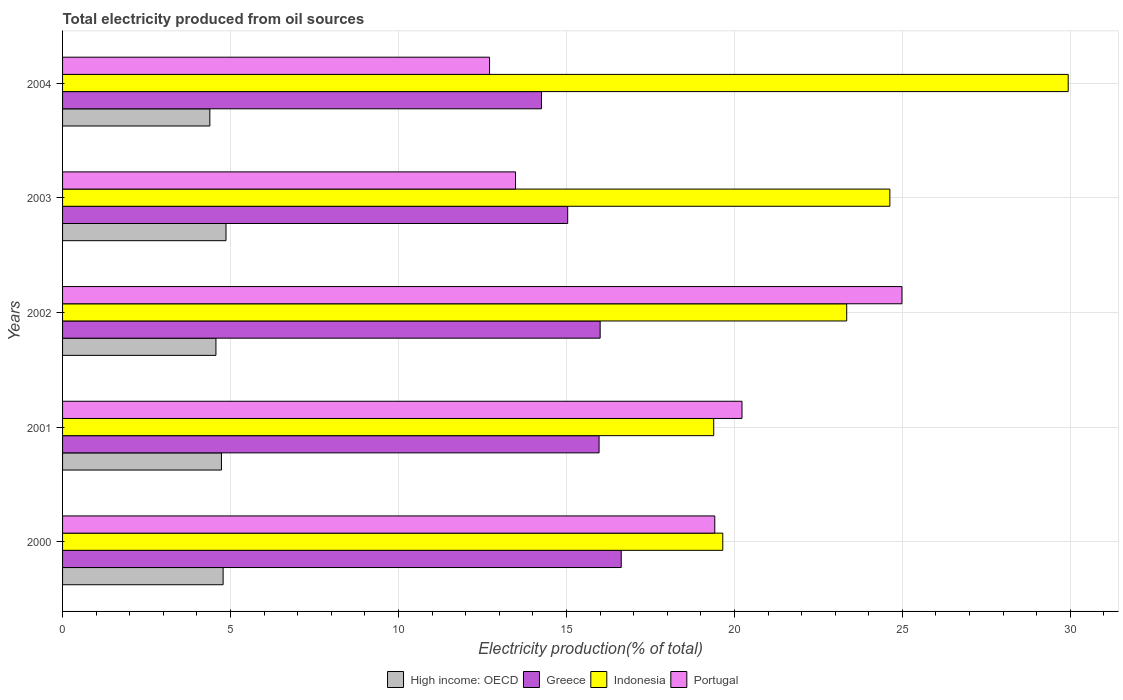How many different coloured bars are there?
Provide a short and direct response. 4. What is the label of the 1st group of bars from the top?
Ensure brevity in your answer.  2004. What is the total electricity produced in Portugal in 2002?
Provide a succinct answer. 24.99. Across all years, what is the maximum total electricity produced in Portugal?
Provide a succinct answer. 24.99. Across all years, what is the minimum total electricity produced in Greece?
Ensure brevity in your answer.  14.26. In which year was the total electricity produced in Indonesia maximum?
Ensure brevity in your answer.  2004. What is the total total electricity produced in High income: OECD in the graph?
Provide a short and direct response. 23.33. What is the difference between the total electricity produced in Portugal in 2000 and that in 2002?
Offer a terse response. -5.57. What is the difference between the total electricity produced in Indonesia in 2000 and the total electricity produced in High income: OECD in 2002?
Your answer should be compact. 15.09. What is the average total electricity produced in Greece per year?
Provide a short and direct response. 15.58. In the year 2001, what is the difference between the total electricity produced in Portugal and total electricity produced in Greece?
Provide a short and direct response. 4.25. What is the ratio of the total electricity produced in Portugal in 2003 to that in 2004?
Offer a very short reply. 1.06. Is the difference between the total electricity produced in Portugal in 2003 and 2004 greater than the difference between the total electricity produced in Greece in 2003 and 2004?
Make the answer very short. No. What is the difference between the highest and the second highest total electricity produced in High income: OECD?
Make the answer very short. 0.09. What is the difference between the highest and the lowest total electricity produced in Portugal?
Your answer should be very brief. 12.28. Is the sum of the total electricity produced in Portugal in 2001 and 2003 greater than the maximum total electricity produced in Greece across all years?
Offer a terse response. Yes. What does the 3rd bar from the top in 2003 represents?
Keep it short and to the point. Greece. What does the 1st bar from the bottom in 2004 represents?
Your answer should be compact. High income: OECD. How many bars are there?
Provide a short and direct response. 20. What is the difference between two consecutive major ticks on the X-axis?
Offer a very short reply. 5. Does the graph contain any zero values?
Offer a terse response. No. Where does the legend appear in the graph?
Your answer should be very brief. Bottom center. How many legend labels are there?
Your response must be concise. 4. How are the legend labels stacked?
Provide a short and direct response. Horizontal. What is the title of the graph?
Keep it short and to the point. Total electricity produced from oil sources. What is the Electricity production(% of total) of High income: OECD in 2000?
Provide a succinct answer. 4.78. What is the Electricity production(% of total) in Greece in 2000?
Your response must be concise. 16.63. What is the Electricity production(% of total) in Indonesia in 2000?
Offer a terse response. 19.65. What is the Electricity production(% of total) of Portugal in 2000?
Give a very brief answer. 19.42. What is the Electricity production(% of total) in High income: OECD in 2001?
Provide a short and direct response. 4.73. What is the Electricity production(% of total) in Greece in 2001?
Ensure brevity in your answer.  15.97. What is the Electricity production(% of total) of Indonesia in 2001?
Offer a terse response. 19.38. What is the Electricity production(% of total) in Portugal in 2001?
Ensure brevity in your answer.  20.23. What is the Electricity production(% of total) of High income: OECD in 2002?
Offer a very short reply. 4.57. What is the Electricity production(% of total) in Greece in 2002?
Your response must be concise. 16. What is the Electricity production(% of total) in Indonesia in 2002?
Your answer should be very brief. 23.34. What is the Electricity production(% of total) in Portugal in 2002?
Your response must be concise. 24.99. What is the Electricity production(% of total) of High income: OECD in 2003?
Ensure brevity in your answer.  4.87. What is the Electricity production(% of total) in Greece in 2003?
Keep it short and to the point. 15.04. What is the Electricity production(% of total) of Indonesia in 2003?
Your response must be concise. 24.63. What is the Electricity production(% of total) in Portugal in 2003?
Your answer should be compact. 13.48. What is the Electricity production(% of total) of High income: OECD in 2004?
Give a very brief answer. 4.38. What is the Electricity production(% of total) of Greece in 2004?
Keep it short and to the point. 14.26. What is the Electricity production(% of total) in Indonesia in 2004?
Provide a succinct answer. 29.94. What is the Electricity production(% of total) of Portugal in 2004?
Keep it short and to the point. 12.71. Across all years, what is the maximum Electricity production(% of total) of High income: OECD?
Give a very brief answer. 4.87. Across all years, what is the maximum Electricity production(% of total) of Greece?
Give a very brief answer. 16.63. Across all years, what is the maximum Electricity production(% of total) of Indonesia?
Make the answer very short. 29.94. Across all years, what is the maximum Electricity production(% of total) in Portugal?
Make the answer very short. 24.99. Across all years, what is the minimum Electricity production(% of total) in High income: OECD?
Make the answer very short. 4.38. Across all years, what is the minimum Electricity production(% of total) in Greece?
Your answer should be compact. 14.26. Across all years, what is the minimum Electricity production(% of total) of Indonesia?
Your response must be concise. 19.38. Across all years, what is the minimum Electricity production(% of total) in Portugal?
Your answer should be compact. 12.71. What is the total Electricity production(% of total) of High income: OECD in the graph?
Offer a terse response. 23.33. What is the total Electricity production(% of total) of Greece in the graph?
Provide a short and direct response. 77.9. What is the total Electricity production(% of total) in Indonesia in the graph?
Provide a short and direct response. 116.94. What is the total Electricity production(% of total) in Portugal in the graph?
Your response must be concise. 90.83. What is the difference between the Electricity production(% of total) in High income: OECD in 2000 and that in 2001?
Make the answer very short. 0.05. What is the difference between the Electricity production(% of total) in Greece in 2000 and that in 2001?
Offer a terse response. 0.66. What is the difference between the Electricity production(% of total) in Indonesia in 2000 and that in 2001?
Your answer should be compact. 0.27. What is the difference between the Electricity production(% of total) in Portugal in 2000 and that in 2001?
Your answer should be compact. -0.81. What is the difference between the Electricity production(% of total) in High income: OECD in 2000 and that in 2002?
Offer a terse response. 0.21. What is the difference between the Electricity production(% of total) of Greece in 2000 and that in 2002?
Your answer should be compact. 0.63. What is the difference between the Electricity production(% of total) of Indonesia in 2000 and that in 2002?
Provide a succinct answer. -3.69. What is the difference between the Electricity production(% of total) of Portugal in 2000 and that in 2002?
Give a very brief answer. -5.57. What is the difference between the Electricity production(% of total) of High income: OECD in 2000 and that in 2003?
Give a very brief answer. -0.09. What is the difference between the Electricity production(% of total) in Greece in 2000 and that in 2003?
Make the answer very short. 1.59. What is the difference between the Electricity production(% of total) in Indonesia in 2000 and that in 2003?
Provide a short and direct response. -4.97. What is the difference between the Electricity production(% of total) of Portugal in 2000 and that in 2003?
Provide a short and direct response. 5.93. What is the difference between the Electricity production(% of total) of High income: OECD in 2000 and that in 2004?
Your response must be concise. 0.4. What is the difference between the Electricity production(% of total) in Greece in 2000 and that in 2004?
Your response must be concise. 2.37. What is the difference between the Electricity production(% of total) of Indonesia in 2000 and that in 2004?
Ensure brevity in your answer.  -10.28. What is the difference between the Electricity production(% of total) in Portugal in 2000 and that in 2004?
Your answer should be compact. 6.7. What is the difference between the Electricity production(% of total) in High income: OECD in 2001 and that in 2002?
Give a very brief answer. 0.16. What is the difference between the Electricity production(% of total) of Greece in 2001 and that in 2002?
Your response must be concise. -0.03. What is the difference between the Electricity production(% of total) in Indonesia in 2001 and that in 2002?
Offer a terse response. -3.96. What is the difference between the Electricity production(% of total) of Portugal in 2001 and that in 2002?
Your response must be concise. -4.76. What is the difference between the Electricity production(% of total) in High income: OECD in 2001 and that in 2003?
Your answer should be very brief. -0.14. What is the difference between the Electricity production(% of total) of Greece in 2001 and that in 2003?
Your answer should be very brief. 0.93. What is the difference between the Electricity production(% of total) of Indonesia in 2001 and that in 2003?
Offer a terse response. -5.24. What is the difference between the Electricity production(% of total) in Portugal in 2001 and that in 2003?
Keep it short and to the point. 6.74. What is the difference between the Electricity production(% of total) of High income: OECD in 2001 and that in 2004?
Provide a succinct answer. 0.35. What is the difference between the Electricity production(% of total) of Greece in 2001 and that in 2004?
Your answer should be compact. 1.71. What is the difference between the Electricity production(% of total) in Indonesia in 2001 and that in 2004?
Your response must be concise. -10.55. What is the difference between the Electricity production(% of total) of Portugal in 2001 and that in 2004?
Your response must be concise. 7.51. What is the difference between the Electricity production(% of total) of High income: OECD in 2002 and that in 2003?
Your answer should be very brief. -0.3. What is the difference between the Electricity production(% of total) of Greece in 2002 and that in 2003?
Give a very brief answer. 0.97. What is the difference between the Electricity production(% of total) of Indonesia in 2002 and that in 2003?
Provide a succinct answer. -1.28. What is the difference between the Electricity production(% of total) in Portugal in 2002 and that in 2003?
Provide a succinct answer. 11.5. What is the difference between the Electricity production(% of total) of High income: OECD in 2002 and that in 2004?
Your response must be concise. 0.18. What is the difference between the Electricity production(% of total) of Greece in 2002 and that in 2004?
Provide a succinct answer. 1.75. What is the difference between the Electricity production(% of total) in Indonesia in 2002 and that in 2004?
Your answer should be compact. -6.59. What is the difference between the Electricity production(% of total) in Portugal in 2002 and that in 2004?
Offer a terse response. 12.28. What is the difference between the Electricity production(% of total) in High income: OECD in 2003 and that in 2004?
Your answer should be compact. 0.48. What is the difference between the Electricity production(% of total) in Greece in 2003 and that in 2004?
Ensure brevity in your answer.  0.78. What is the difference between the Electricity production(% of total) of Indonesia in 2003 and that in 2004?
Offer a very short reply. -5.31. What is the difference between the Electricity production(% of total) in Portugal in 2003 and that in 2004?
Provide a short and direct response. 0.77. What is the difference between the Electricity production(% of total) in High income: OECD in 2000 and the Electricity production(% of total) in Greece in 2001?
Make the answer very short. -11.19. What is the difference between the Electricity production(% of total) in High income: OECD in 2000 and the Electricity production(% of total) in Indonesia in 2001?
Keep it short and to the point. -14.6. What is the difference between the Electricity production(% of total) of High income: OECD in 2000 and the Electricity production(% of total) of Portugal in 2001?
Offer a terse response. -15.45. What is the difference between the Electricity production(% of total) in Greece in 2000 and the Electricity production(% of total) in Indonesia in 2001?
Your response must be concise. -2.75. What is the difference between the Electricity production(% of total) of Greece in 2000 and the Electricity production(% of total) of Portugal in 2001?
Ensure brevity in your answer.  -3.6. What is the difference between the Electricity production(% of total) in Indonesia in 2000 and the Electricity production(% of total) in Portugal in 2001?
Provide a short and direct response. -0.57. What is the difference between the Electricity production(% of total) of High income: OECD in 2000 and the Electricity production(% of total) of Greece in 2002?
Offer a terse response. -11.22. What is the difference between the Electricity production(% of total) of High income: OECD in 2000 and the Electricity production(% of total) of Indonesia in 2002?
Your answer should be compact. -18.56. What is the difference between the Electricity production(% of total) in High income: OECD in 2000 and the Electricity production(% of total) in Portugal in 2002?
Ensure brevity in your answer.  -20.21. What is the difference between the Electricity production(% of total) of Greece in 2000 and the Electricity production(% of total) of Indonesia in 2002?
Your response must be concise. -6.71. What is the difference between the Electricity production(% of total) of Greece in 2000 and the Electricity production(% of total) of Portugal in 2002?
Keep it short and to the point. -8.36. What is the difference between the Electricity production(% of total) in Indonesia in 2000 and the Electricity production(% of total) in Portugal in 2002?
Make the answer very short. -5.33. What is the difference between the Electricity production(% of total) in High income: OECD in 2000 and the Electricity production(% of total) in Greece in 2003?
Give a very brief answer. -10.26. What is the difference between the Electricity production(% of total) in High income: OECD in 2000 and the Electricity production(% of total) in Indonesia in 2003?
Provide a short and direct response. -19.85. What is the difference between the Electricity production(% of total) of High income: OECD in 2000 and the Electricity production(% of total) of Portugal in 2003?
Your answer should be compact. -8.7. What is the difference between the Electricity production(% of total) of Greece in 2000 and the Electricity production(% of total) of Indonesia in 2003?
Make the answer very short. -8. What is the difference between the Electricity production(% of total) of Greece in 2000 and the Electricity production(% of total) of Portugal in 2003?
Provide a short and direct response. 3.15. What is the difference between the Electricity production(% of total) in Indonesia in 2000 and the Electricity production(% of total) in Portugal in 2003?
Your response must be concise. 6.17. What is the difference between the Electricity production(% of total) of High income: OECD in 2000 and the Electricity production(% of total) of Greece in 2004?
Provide a succinct answer. -9.48. What is the difference between the Electricity production(% of total) of High income: OECD in 2000 and the Electricity production(% of total) of Indonesia in 2004?
Keep it short and to the point. -25.16. What is the difference between the Electricity production(% of total) in High income: OECD in 2000 and the Electricity production(% of total) in Portugal in 2004?
Give a very brief answer. -7.93. What is the difference between the Electricity production(% of total) in Greece in 2000 and the Electricity production(% of total) in Indonesia in 2004?
Give a very brief answer. -13.31. What is the difference between the Electricity production(% of total) in Greece in 2000 and the Electricity production(% of total) in Portugal in 2004?
Your answer should be compact. 3.92. What is the difference between the Electricity production(% of total) of Indonesia in 2000 and the Electricity production(% of total) of Portugal in 2004?
Keep it short and to the point. 6.94. What is the difference between the Electricity production(% of total) in High income: OECD in 2001 and the Electricity production(% of total) in Greece in 2002?
Offer a very short reply. -11.27. What is the difference between the Electricity production(% of total) of High income: OECD in 2001 and the Electricity production(% of total) of Indonesia in 2002?
Your answer should be very brief. -18.61. What is the difference between the Electricity production(% of total) of High income: OECD in 2001 and the Electricity production(% of total) of Portugal in 2002?
Your answer should be very brief. -20.26. What is the difference between the Electricity production(% of total) of Greece in 2001 and the Electricity production(% of total) of Indonesia in 2002?
Provide a short and direct response. -7.37. What is the difference between the Electricity production(% of total) in Greece in 2001 and the Electricity production(% of total) in Portugal in 2002?
Your answer should be very brief. -9.02. What is the difference between the Electricity production(% of total) of Indonesia in 2001 and the Electricity production(% of total) of Portugal in 2002?
Your answer should be very brief. -5.6. What is the difference between the Electricity production(% of total) in High income: OECD in 2001 and the Electricity production(% of total) in Greece in 2003?
Make the answer very short. -10.31. What is the difference between the Electricity production(% of total) of High income: OECD in 2001 and the Electricity production(% of total) of Indonesia in 2003?
Ensure brevity in your answer.  -19.9. What is the difference between the Electricity production(% of total) of High income: OECD in 2001 and the Electricity production(% of total) of Portugal in 2003?
Offer a terse response. -8.75. What is the difference between the Electricity production(% of total) in Greece in 2001 and the Electricity production(% of total) in Indonesia in 2003?
Offer a terse response. -8.66. What is the difference between the Electricity production(% of total) in Greece in 2001 and the Electricity production(% of total) in Portugal in 2003?
Your response must be concise. 2.49. What is the difference between the Electricity production(% of total) of Indonesia in 2001 and the Electricity production(% of total) of Portugal in 2003?
Your answer should be very brief. 5.9. What is the difference between the Electricity production(% of total) in High income: OECD in 2001 and the Electricity production(% of total) in Greece in 2004?
Your answer should be very brief. -9.53. What is the difference between the Electricity production(% of total) in High income: OECD in 2001 and the Electricity production(% of total) in Indonesia in 2004?
Give a very brief answer. -25.21. What is the difference between the Electricity production(% of total) in High income: OECD in 2001 and the Electricity production(% of total) in Portugal in 2004?
Offer a terse response. -7.98. What is the difference between the Electricity production(% of total) of Greece in 2001 and the Electricity production(% of total) of Indonesia in 2004?
Your response must be concise. -13.97. What is the difference between the Electricity production(% of total) in Greece in 2001 and the Electricity production(% of total) in Portugal in 2004?
Keep it short and to the point. 3.26. What is the difference between the Electricity production(% of total) of Indonesia in 2001 and the Electricity production(% of total) of Portugal in 2004?
Your answer should be compact. 6.67. What is the difference between the Electricity production(% of total) in High income: OECD in 2002 and the Electricity production(% of total) in Greece in 2003?
Make the answer very short. -10.47. What is the difference between the Electricity production(% of total) in High income: OECD in 2002 and the Electricity production(% of total) in Indonesia in 2003?
Provide a succinct answer. -20.06. What is the difference between the Electricity production(% of total) of High income: OECD in 2002 and the Electricity production(% of total) of Portugal in 2003?
Provide a succinct answer. -8.92. What is the difference between the Electricity production(% of total) of Greece in 2002 and the Electricity production(% of total) of Indonesia in 2003?
Give a very brief answer. -8.62. What is the difference between the Electricity production(% of total) of Greece in 2002 and the Electricity production(% of total) of Portugal in 2003?
Offer a very short reply. 2.52. What is the difference between the Electricity production(% of total) in Indonesia in 2002 and the Electricity production(% of total) in Portugal in 2003?
Provide a succinct answer. 9.86. What is the difference between the Electricity production(% of total) in High income: OECD in 2002 and the Electricity production(% of total) in Greece in 2004?
Make the answer very short. -9.69. What is the difference between the Electricity production(% of total) in High income: OECD in 2002 and the Electricity production(% of total) in Indonesia in 2004?
Provide a succinct answer. -25.37. What is the difference between the Electricity production(% of total) of High income: OECD in 2002 and the Electricity production(% of total) of Portugal in 2004?
Keep it short and to the point. -8.15. What is the difference between the Electricity production(% of total) in Greece in 2002 and the Electricity production(% of total) in Indonesia in 2004?
Offer a terse response. -13.93. What is the difference between the Electricity production(% of total) in Greece in 2002 and the Electricity production(% of total) in Portugal in 2004?
Provide a short and direct response. 3.29. What is the difference between the Electricity production(% of total) in Indonesia in 2002 and the Electricity production(% of total) in Portugal in 2004?
Keep it short and to the point. 10.63. What is the difference between the Electricity production(% of total) in High income: OECD in 2003 and the Electricity production(% of total) in Greece in 2004?
Ensure brevity in your answer.  -9.39. What is the difference between the Electricity production(% of total) of High income: OECD in 2003 and the Electricity production(% of total) of Indonesia in 2004?
Ensure brevity in your answer.  -25.07. What is the difference between the Electricity production(% of total) in High income: OECD in 2003 and the Electricity production(% of total) in Portugal in 2004?
Provide a succinct answer. -7.85. What is the difference between the Electricity production(% of total) of Greece in 2003 and the Electricity production(% of total) of Indonesia in 2004?
Make the answer very short. -14.9. What is the difference between the Electricity production(% of total) in Greece in 2003 and the Electricity production(% of total) in Portugal in 2004?
Offer a terse response. 2.33. What is the difference between the Electricity production(% of total) in Indonesia in 2003 and the Electricity production(% of total) in Portugal in 2004?
Make the answer very short. 11.92. What is the average Electricity production(% of total) of High income: OECD per year?
Offer a very short reply. 4.67. What is the average Electricity production(% of total) in Greece per year?
Your response must be concise. 15.58. What is the average Electricity production(% of total) of Indonesia per year?
Give a very brief answer. 23.39. What is the average Electricity production(% of total) of Portugal per year?
Your response must be concise. 18.16. In the year 2000, what is the difference between the Electricity production(% of total) in High income: OECD and Electricity production(% of total) in Greece?
Your answer should be very brief. -11.85. In the year 2000, what is the difference between the Electricity production(% of total) of High income: OECD and Electricity production(% of total) of Indonesia?
Make the answer very short. -14.87. In the year 2000, what is the difference between the Electricity production(% of total) of High income: OECD and Electricity production(% of total) of Portugal?
Offer a terse response. -14.64. In the year 2000, what is the difference between the Electricity production(% of total) in Greece and Electricity production(% of total) in Indonesia?
Make the answer very short. -3.02. In the year 2000, what is the difference between the Electricity production(% of total) in Greece and Electricity production(% of total) in Portugal?
Provide a succinct answer. -2.79. In the year 2000, what is the difference between the Electricity production(% of total) of Indonesia and Electricity production(% of total) of Portugal?
Provide a short and direct response. 0.24. In the year 2001, what is the difference between the Electricity production(% of total) in High income: OECD and Electricity production(% of total) in Greece?
Keep it short and to the point. -11.24. In the year 2001, what is the difference between the Electricity production(% of total) of High income: OECD and Electricity production(% of total) of Indonesia?
Your answer should be very brief. -14.65. In the year 2001, what is the difference between the Electricity production(% of total) of High income: OECD and Electricity production(% of total) of Portugal?
Give a very brief answer. -15.5. In the year 2001, what is the difference between the Electricity production(% of total) of Greece and Electricity production(% of total) of Indonesia?
Offer a terse response. -3.41. In the year 2001, what is the difference between the Electricity production(% of total) in Greece and Electricity production(% of total) in Portugal?
Your response must be concise. -4.25. In the year 2001, what is the difference between the Electricity production(% of total) of Indonesia and Electricity production(% of total) of Portugal?
Your response must be concise. -0.84. In the year 2002, what is the difference between the Electricity production(% of total) of High income: OECD and Electricity production(% of total) of Greece?
Keep it short and to the point. -11.44. In the year 2002, what is the difference between the Electricity production(% of total) of High income: OECD and Electricity production(% of total) of Indonesia?
Your answer should be very brief. -18.78. In the year 2002, what is the difference between the Electricity production(% of total) of High income: OECD and Electricity production(% of total) of Portugal?
Provide a succinct answer. -20.42. In the year 2002, what is the difference between the Electricity production(% of total) in Greece and Electricity production(% of total) in Indonesia?
Give a very brief answer. -7.34. In the year 2002, what is the difference between the Electricity production(% of total) in Greece and Electricity production(% of total) in Portugal?
Make the answer very short. -8.98. In the year 2002, what is the difference between the Electricity production(% of total) of Indonesia and Electricity production(% of total) of Portugal?
Offer a very short reply. -1.65. In the year 2003, what is the difference between the Electricity production(% of total) in High income: OECD and Electricity production(% of total) in Greece?
Offer a terse response. -10.17. In the year 2003, what is the difference between the Electricity production(% of total) in High income: OECD and Electricity production(% of total) in Indonesia?
Ensure brevity in your answer.  -19.76. In the year 2003, what is the difference between the Electricity production(% of total) of High income: OECD and Electricity production(% of total) of Portugal?
Your response must be concise. -8.62. In the year 2003, what is the difference between the Electricity production(% of total) in Greece and Electricity production(% of total) in Indonesia?
Make the answer very short. -9.59. In the year 2003, what is the difference between the Electricity production(% of total) in Greece and Electricity production(% of total) in Portugal?
Make the answer very short. 1.55. In the year 2003, what is the difference between the Electricity production(% of total) in Indonesia and Electricity production(% of total) in Portugal?
Offer a very short reply. 11.14. In the year 2004, what is the difference between the Electricity production(% of total) of High income: OECD and Electricity production(% of total) of Greece?
Give a very brief answer. -9.87. In the year 2004, what is the difference between the Electricity production(% of total) of High income: OECD and Electricity production(% of total) of Indonesia?
Ensure brevity in your answer.  -25.55. In the year 2004, what is the difference between the Electricity production(% of total) in High income: OECD and Electricity production(% of total) in Portugal?
Provide a succinct answer. -8.33. In the year 2004, what is the difference between the Electricity production(% of total) in Greece and Electricity production(% of total) in Indonesia?
Provide a short and direct response. -15.68. In the year 2004, what is the difference between the Electricity production(% of total) in Greece and Electricity production(% of total) in Portugal?
Make the answer very short. 1.55. In the year 2004, what is the difference between the Electricity production(% of total) of Indonesia and Electricity production(% of total) of Portugal?
Ensure brevity in your answer.  17.23. What is the ratio of the Electricity production(% of total) in High income: OECD in 2000 to that in 2001?
Your answer should be very brief. 1.01. What is the ratio of the Electricity production(% of total) in Greece in 2000 to that in 2001?
Keep it short and to the point. 1.04. What is the ratio of the Electricity production(% of total) in Indonesia in 2000 to that in 2001?
Your answer should be compact. 1.01. What is the ratio of the Electricity production(% of total) in Portugal in 2000 to that in 2001?
Ensure brevity in your answer.  0.96. What is the ratio of the Electricity production(% of total) of High income: OECD in 2000 to that in 2002?
Offer a terse response. 1.05. What is the ratio of the Electricity production(% of total) in Greece in 2000 to that in 2002?
Give a very brief answer. 1.04. What is the ratio of the Electricity production(% of total) of Indonesia in 2000 to that in 2002?
Give a very brief answer. 0.84. What is the ratio of the Electricity production(% of total) of Portugal in 2000 to that in 2002?
Your answer should be very brief. 0.78. What is the ratio of the Electricity production(% of total) of High income: OECD in 2000 to that in 2003?
Keep it short and to the point. 0.98. What is the ratio of the Electricity production(% of total) in Greece in 2000 to that in 2003?
Keep it short and to the point. 1.11. What is the ratio of the Electricity production(% of total) of Indonesia in 2000 to that in 2003?
Provide a succinct answer. 0.8. What is the ratio of the Electricity production(% of total) in Portugal in 2000 to that in 2003?
Ensure brevity in your answer.  1.44. What is the ratio of the Electricity production(% of total) of High income: OECD in 2000 to that in 2004?
Provide a short and direct response. 1.09. What is the ratio of the Electricity production(% of total) in Greece in 2000 to that in 2004?
Provide a succinct answer. 1.17. What is the ratio of the Electricity production(% of total) in Indonesia in 2000 to that in 2004?
Provide a succinct answer. 0.66. What is the ratio of the Electricity production(% of total) in Portugal in 2000 to that in 2004?
Provide a short and direct response. 1.53. What is the ratio of the Electricity production(% of total) in High income: OECD in 2001 to that in 2002?
Offer a very short reply. 1.04. What is the ratio of the Electricity production(% of total) of Indonesia in 2001 to that in 2002?
Keep it short and to the point. 0.83. What is the ratio of the Electricity production(% of total) in Portugal in 2001 to that in 2002?
Make the answer very short. 0.81. What is the ratio of the Electricity production(% of total) of High income: OECD in 2001 to that in 2003?
Offer a terse response. 0.97. What is the ratio of the Electricity production(% of total) in Greece in 2001 to that in 2003?
Your answer should be compact. 1.06. What is the ratio of the Electricity production(% of total) of Indonesia in 2001 to that in 2003?
Keep it short and to the point. 0.79. What is the ratio of the Electricity production(% of total) of Portugal in 2001 to that in 2003?
Your answer should be very brief. 1.5. What is the ratio of the Electricity production(% of total) in High income: OECD in 2001 to that in 2004?
Offer a very short reply. 1.08. What is the ratio of the Electricity production(% of total) of Greece in 2001 to that in 2004?
Offer a very short reply. 1.12. What is the ratio of the Electricity production(% of total) in Indonesia in 2001 to that in 2004?
Give a very brief answer. 0.65. What is the ratio of the Electricity production(% of total) in Portugal in 2001 to that in 2004?
Give a very brief answer. 1.59. What is the ratio of the Electricity production(% of total) of High income: OECD in 2002 to that in 2003?
Keep it short and to the point. 0.94. What is the ratio of the Electricity production(% of total) of Greece in 2002 to that in 2003?
Ensure brevity in your answer.  1.06. What is the ratio of the Electricity production(% of total) of Indonesia in 2002 to that in 2003?
Keep it short and to the point. 0.95. What is the ratio of the Electricity production(% of total) in Portugal in 2002 to that in 2003?
Your answer should be compact. 1.85. What is the ratio of the Electricity production(% of total) of High income: OECD in 2002 to that in 2004?
Ensure brevity in your answer.  1.04. What is the ratio of the Electricity production(% of total) in Greece in 2002 to that in 2004?
Offer a terse response. 1.12. What is the ratio of the Electricity production(% of total) of Indonesia in 2002 to that in 2004?
Ensure brevity in your answer.  0.78. What is the ratio of the Electricity production(% of total) of Portugal in 2002 to that in 2004?
Offer a very short reply. 1.97. What is the ratio of the Electricity production(% of total) of High income: OECD in 2003 to that in 2004?
Offer a terse response. 1.11. What is the ratio of the Electricity production(% of total) of Greece in 2003 to that in 2004?
Provide a short and direct response. 1.05. What is the ratio of the Electricity production(% of total) of Indonesia in 2003 to that in 2004?
Offer a very short reply. 0.82. What is the ratio of the Electricity production(% of total) in Portugal in 2003 to that in 2004?
Offer a terse response. 1.06. What is the difference between the highest and the second highest Electricity production(% of total) of High income: OECD?
Your answer should be compact. 0.09. What is the difference between the highest and the second highest Electricity production(% of total) in Greece?
Provide a short and direct response. 0.63. What is the difference between the highest and the second highest Electricity production(% of total) in Indonesia?
Your answer should be compact. 5.31. What is the difference between the highest and the second highest Electricity production(% of total) of Portugal?
Provide a succinct answer. 4.76. What is the difference between the highest and the lowest Electricity production(% of total) of High income: OECD?
Provide a succinct answer. 0.48. What is the difference between the highest and the lowest Electricity production(% of total) in Greece?
Your response must be concise. 2.37. What is the difference between the highest and the lowest Electricity production(% of total) in Indonesia?
Your answer should be compact. 10.55. What is the difference between the highest and the lowest Electricity production(% of total) of Portugal?
Your answer should be compact. 12.28. 